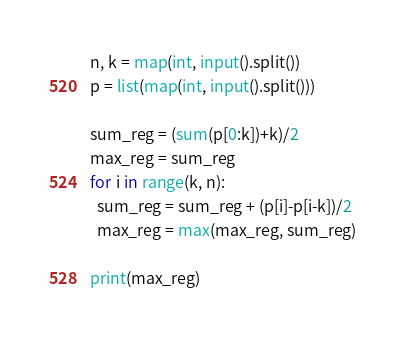Convert code to text. <code><loc_0><loc_0><loc_500><loc_500><_Python_>n, k = map(int, input().split())
p = list(map(int, input().split()))

sum_reg = (sum(p[0:k])+k)/2
max_reg = sum_reg
for i in range(k, n):
  sum_reg = sum_reg + (p[i]-p[i-k])/2
  max_reg = max(max_reg, sum_reg)
  
print(max_reg)</code> 